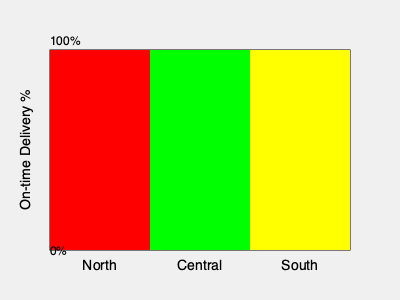Based on the color-coded map showing delivery performance across regions, which region has the highest percentage of on-time deliveries, and what action should be taken for the region with the lowest performance? To answer this question, we need to analyze the color-coded map and interpret the data:

1. The map shows three regions: North, Central, and South.
2. Each region is represented by a colored bar, where the height of the bar indicates the on-time delivery percentage.
3. The color coding is as follows:
   - Red: lowest performance
   - Yellow: medium performance
   - Green: highest performance

4. Analyzing the map:
   - North (left) is colored red and has the shortest bar
   - Central (middle) is colored green and has the tallest bar
   - South (right) is colored yellow and has a medium-height bar

5. Based on this analysis, we can conclude that the Central region has the highest percentage of on-time deliveries.

6. For the region with the lowest performance (North):
   - As a government agency responsible for monitoring and enforcing delivery standards, we should take action to improve performance.
   - This action should involve investigating the reasons for poor performance and implementing corrective measures.

Therefore, the Central region has the highest on-time delivery percentage, and for the North region (lowest performance), an investigation and corrective action plan should be implemented.
Answer: Central region; Investigate and implement corrective measures in the North region. 